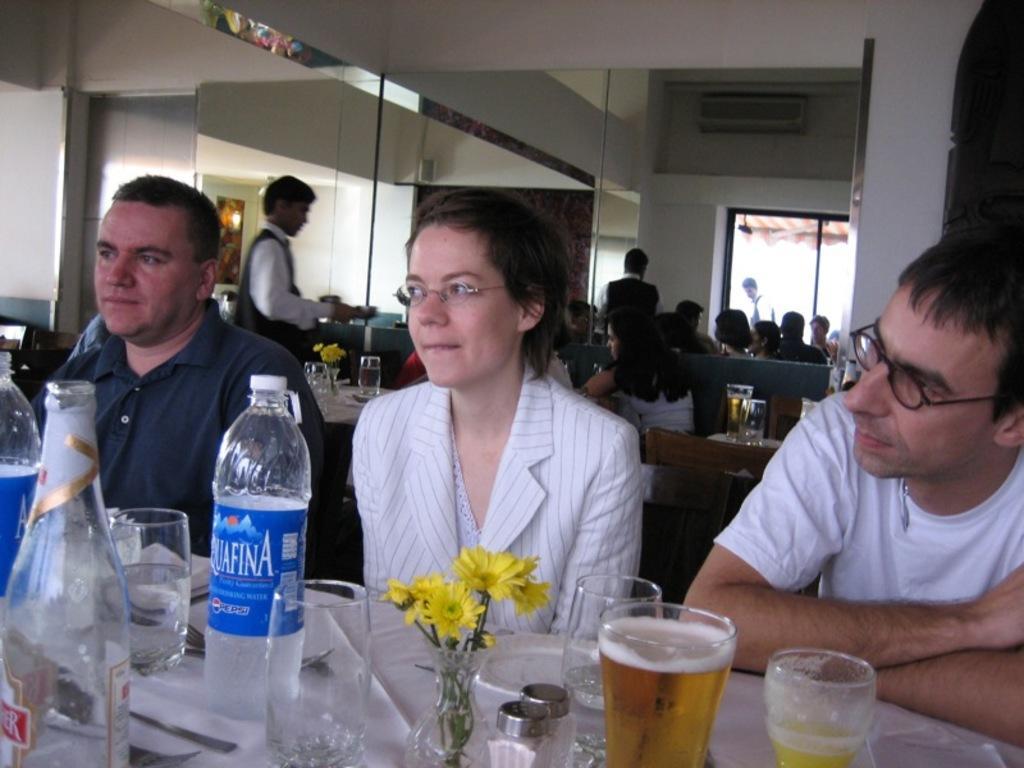Please provide a concise description of this image. There are three members sitting. There is a men with the white t-shirt is sitting in the right corner. And the lady with the white jacket is sitting in the middle. And the men with the blue t-shirt is sitting in the left side. IN front of them there is a table. on the table there is a bottle, glass, flower vase with flowers, plate, spoons. Behind them there are many people sitting on a sofa. And there is a man standing. And we can also see a window. 